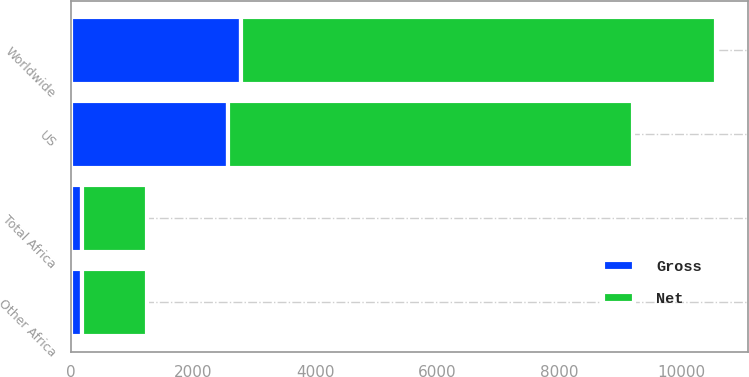Convert chart. <chart><loc_0><loc_0><loc_500><loc_500><stacked_bar_chart><ecel><fcel>US<fcel>Other Africa<fcel>Total Africa<fcel>Worldwide<nl><fcel>Net<fcel>6632<fcel>1072<fcel>1072<fcel>7781<nl><fcel>Gross<fcel>2568<fcel>175<fcel>175<fcel>2777<nl></chart> 